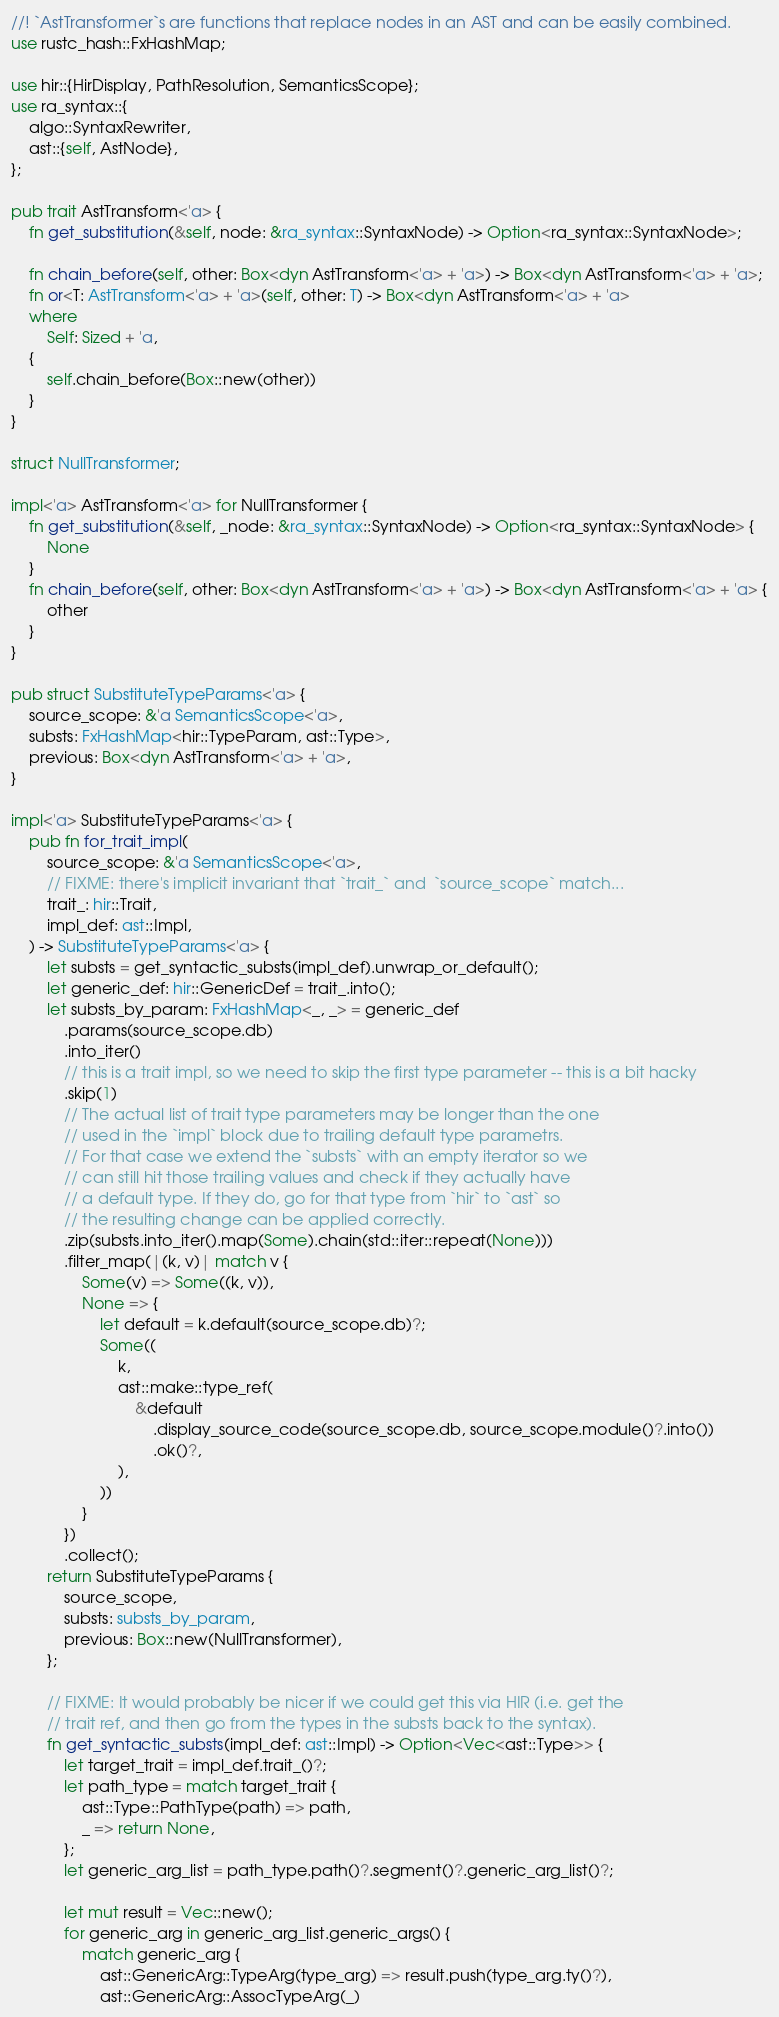<code> <loc_0><loc_0><loc_500><loc_500><_Rust_>//! `AstTransformer`s are functions that replace nodes in an AST and can be easily combined.
use rustc_hash::FxHashMap;

use hir::{HirDisplay, PathResolution, SemanticsScope};
use ra_syntax::{
    algo::SyntaxRewriter,
    ast::{self, AstNode},
};

pub trait AstTransform<'a> {
    fn get_substitution(&self, node: &ra_syntax::SyntaxNode) -> Option<ra_syntax::SyntaxNode>;

    fn chain_before(self, other: Box<dyn AstTransform<'a> + 'a>) -> Box<dyn AstTransform<'a> + 'a>;
    fn or<T: AstTransform<'a> + 'a>(self, other: T) -> Box<dyn AstTransform<'a> + 'a>
    where
        Self: Sized + 'a,
    {
        self.chain_before(Box::new(other))
    }
}

struct NullTransformer;

impl<'a> AstTransform<'a> for NullTransformer {
    fn get_substitution(&self, _node: &ra_syntax::SyntaxNode) -> Option<ra_syntax::SyntaxNode> {
        None
    }
    fn chain_before(self, other: Box<dyn AstTransform<'a> + 'a>) -> Box<dyn AstTransform<'a> + 'a> {
        other
    }
}

pub struct SubstituteTypeParams<'a> {
    source_scope: &'a SemanticsScope<'a>,
    substs: FxHashMap<hir::TypeParam, ast::Type>,
    previous: Box<dyn AstTransform<'a> + 'a>,
}

impl<'a> SubstituteTypeParams<'a> {
    pub fn for_trait_impl(
        source_scope: &'a SemanticsScope<'a>,
        // FIXME: there's implicit invariant that `trait_` and  `source_scope` match...
        trait_: hir::Trait,
        impl_def: ast::Impl,
    ) -> SubstituteTypeParams<'a> {
        let substs = get_syntactic_substs(impl_def).unwrap_or_default();
        let generic_def: hir::GenericDef = trait_.into();
        let substs_by_param: FxHashMap<_, _> = generic_def
            .params(source_scope.db)
            .into_iter()
            // this is a trait impl, so we need to skip the first type parameter -- this is a bit hacky
            .skip(1)
            // The actual list of trait type parameters may be longer than the one
            // used in the `impl` block due to trailing default type parametrs.
            // For that case we extend the `substs` with an empty iterator so we
            // can still hit those trailing values and check if they actually have
            // a default type. If they do, go for that type from `hir` to `ast` so
            // the resulting change can be applied correctly.
            .zip(substs.into_iter().map(Some).chain(std::iter::repeat(None)))
            .filter_map(|(k, v)| match v {
                Some(v) => Some((k, v)),
                None => {
                    let default = k.default(source_scope.db)?;
                    Some((
                        k,
                        ast::make::type_ref(
                            &default
                                .display_source_code(source_scope.db, source_scope.module()?.into())
                                .ok()?,
                        ),
                    ))
                }
            })
            .collect();
        return SubstituteTypeParams {
            source_scope,
            substs: substs_by_param,
            previous: Box::new(NullTransformer),
        };

        // FIXME: It would probably be nicer if we could get this via HIR (i.e. get the
        // trait ref, and then go from the types in the substs back to the syntax).
        fn get_syntactic_substs(impl_def: ast::Impl) -> Option<Vec<ast::Type>> {
            let target_trait = impl_def.trait_()?;
            let path_type = match target_trait {
                ast::Type::PathType(path) => path,
                _ => return None,
            };
            let generic_arg_list = path_type.path()?.segment()?.generic_arg_list()?;

            let mut result = Vec::new();
            for generic_arg in generic_arg_list.generic_args() {
                match generic_arg {
                    ast::GenericArg::TypeArg(type_arg) => result.push(type_arg.ty()?),
                    ast::GenericArg::AssocTypeArg(_)</code> 